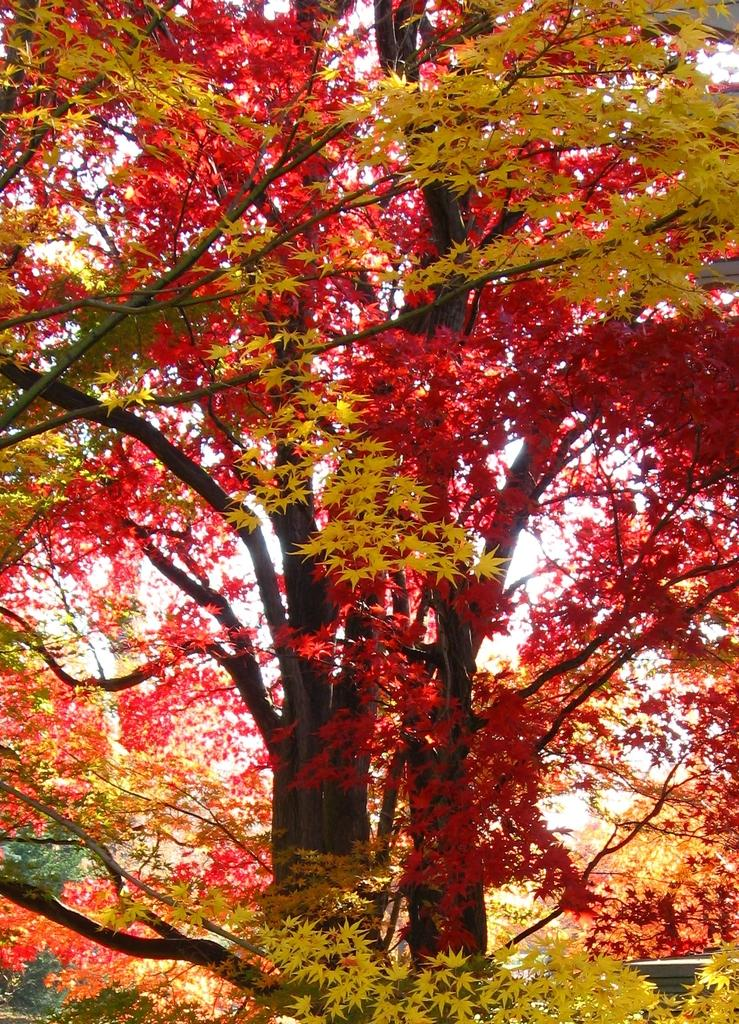What type of vegetation can be seen in the image? There are trees in the image. What colors are the leaves on the trees? The leaves on the trees are red and yellow. What type of art can be seen on the trees in the image? There is no art present on the trees in the image; the leaves are naturally red and yellow. What type of powder is visible on the leaves in the image? There is no powder present on the leaves in the image; the leaves are naturally red and yellow. 